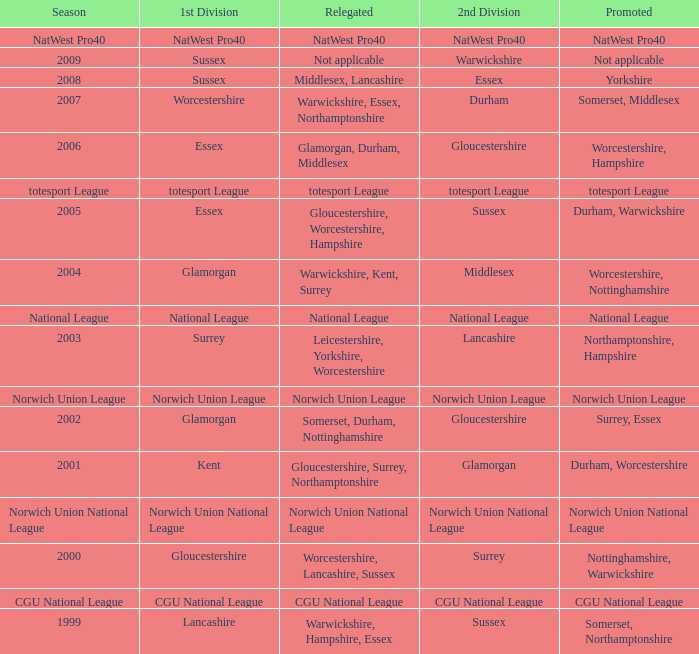If the national league is the 2nd division, what is the name of the 1st division? National League. 